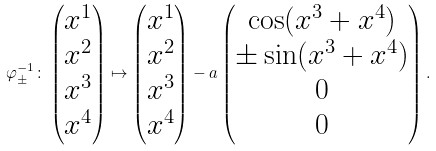<formula> <loc_0><loc_0><loc_500><loc_500>\varphi _ { \pm } ^ { - 1 } \colon \begin{pmatrix} x ^ { 1 } \\ x ^ { 2 } \\ x ^ { 3 } \\ x ^ { 4 } \\ \end{pmatrix} \mapsto \begin{pmatrix} x ^ { 1 } \\ x ^ { 2 } \\ x ^ { 3 } \\ x ^ { 4 } \\ \end{pmatrix} - a \begin{pmatrix} \cos ( x ^ { 3 } + x ^ { 4 } ) \\ \pm \sin ( x ^ { 3 } + x ^ { 4 } ) \\ 0 \\ 0 \end{pmatrix} .</formula> 